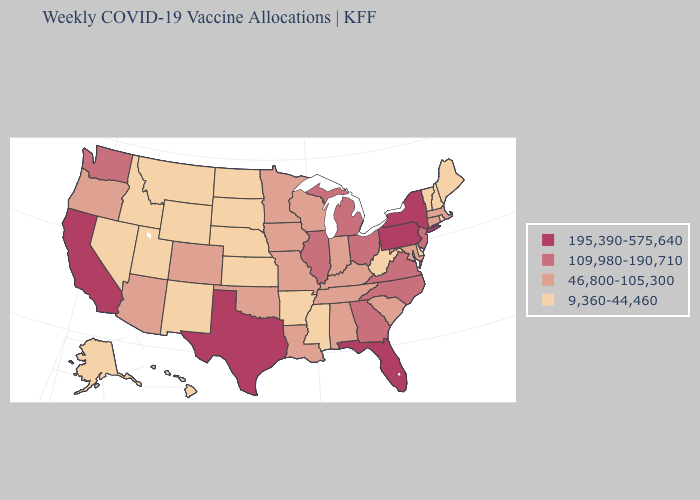How many symbols are there in the legend?
Quick response, please. 4. Which states have the highest value in the USA?
Give a very brief answer. California, Florida, New York, Pennsylvania, Texas. What is the highest value in the MidWest ?
Write a very short answer. 109,980-190,710. What is the value of New Mexico?
Be succinct. 9,360-44,460. Does Ohio have the lowest value in the MidWest?
Keep it brief. No. Among the states that border Illinois , which have the lowest value?
Keep it brief. Indiana, Iowa, Kentucky, Missouri, Wisconsin. Which states hav the highest value in the MidWest?
Short answer required. Illinois, Michigan, Ohio. What is the value of Georgia?
Answer briefly. 109,980-190,710. What is the value of Michigan?
Give a very brief answer. 109,980-190,710. Does Washington have a lower value than Pennsylvania?
Write a very short answer. Yes. What is the value of North Dakota?
Concise answer only. 9,360-44,460. What is the value of Pennsylvania?
Be succinct. 195,390-575,640. What is the lowest value in states that border Nevada?
Quick response, please. 9,360-44,460. What is the value of Michigan?
Give a very brief answer. 109,980-190,710. Among the states that border Missouri , which have the highest value?
Keep it brief. Illinois. 